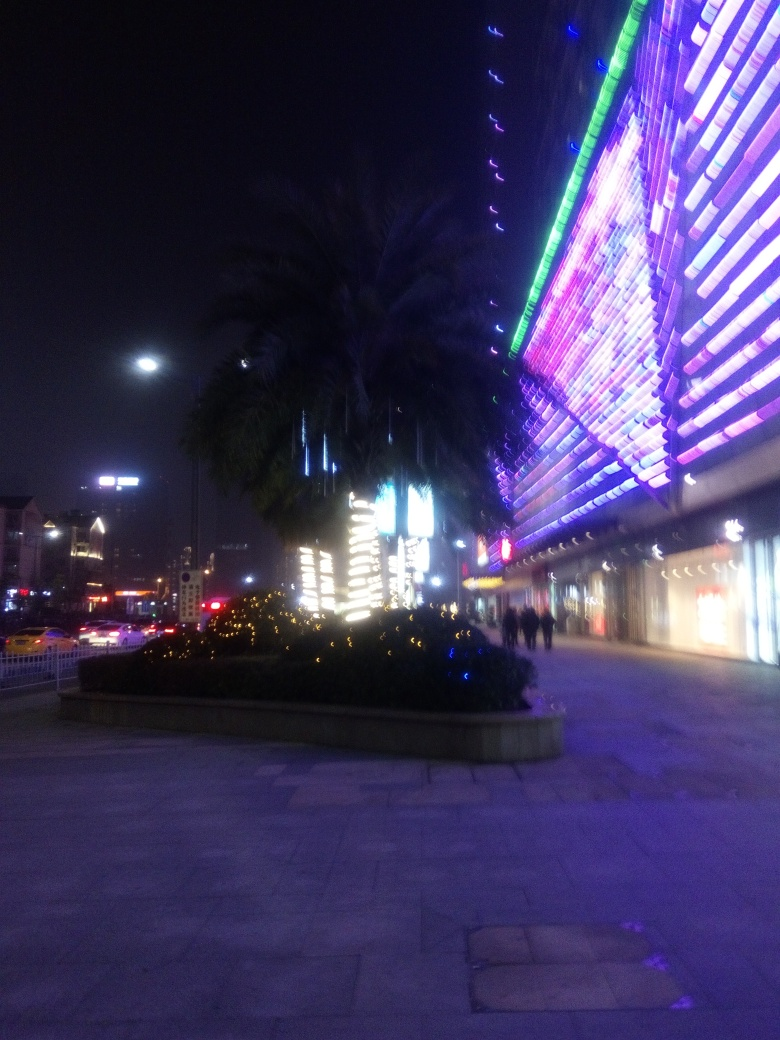Can you describe the atmosphere or mood conveyed by the image? The image conveys a lively urban atmosphere with a mix of vibrant neon lights and a bustling city vibe. The palm tree in the foreground, along with the decorative lights, adds a touch of leisure and festivity to the scene, suggesting a location that balances urbanity with leisure or entertainment options. 